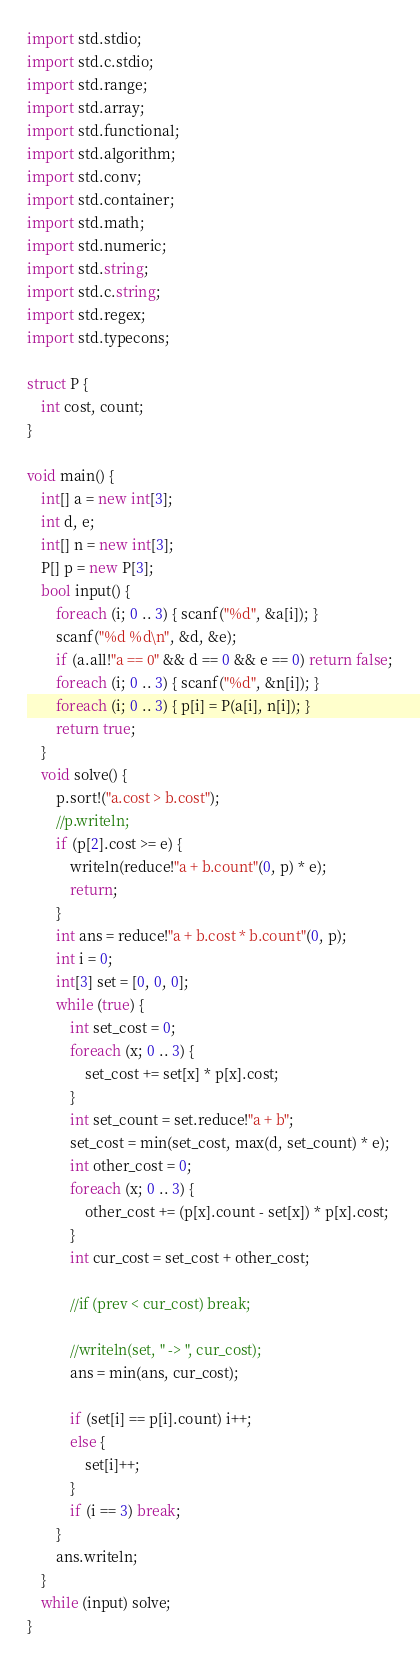<code> <loc_0><loc_0><loc_500><loc_500><_D_>import std.stdio;
import std.c.stdio;
import std.range;
import std.array;
import std.functional;
import std.algorithm;
import std.conv;
import std.container;
import std.math;
import std.numeric;
import std.string;
import std.c.string;
import std.regex;
import std.typecons;

struct P {
    int cost, count;
}
 
void main() {
    int[] a = new int[3];
    int d, e;
    int[] n = new int[3];
    P[] p = new P[3];
    bool input() {
        foreach (i; 0 .. 3) { scanf("%d", &a[i]); }
        scanf("%d %d\n", &d, &e);
        if (a.all!"a == 0" && d == 0 && e == 0) return false;
        foreach (i; 0 .. 3) { scanf("%d", &n[i]); }
        foreach (i; 0 .. 3) { p[i] = P(a[i], n[i]); }
        return true;
    }
    void solve() {
        p.sort!("a.cost > b.cost");
        //p.writeln;
        if (p[2].cost >= e) {
            writeln(reduce!"a + b.count"(0, p) * e);
            return;
        }
        int ans = reduce!"a + b.cost * b.count"(0, p);
        int i = 0;
        int[3] set = [0, 0, 0];
        while (true) {
            int set_cost = 0;
            foreach (x; 0 .. 3) {
                set_cost += set[x] * p[x].cost;
            }
            int set_count = set.reduce!"a + b";
            set_cost = min(set_cost, max(d, set_count) * e);
            int other_cost = 0;
            foreach (x; 0 .. 3) {
                other_cost += (p[x].count - set[x]) * p[x].cost;
            }
            int cur_cost = set_cost + other_cost;

            //if (prev < cur_cost) break;

            //writeln(set, " -> ", cur_cost);
            ans = min(ans, cur_cost);

            if (set[i] == p[i].count) i++;
            else {
                set[i]++;
            }
            if (i == 3) break;
        }
        ans.writeln;
    }
    while (input) solve;
}</code> 